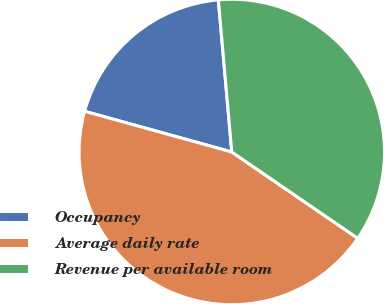<chart> <loc_0><loc_0><loc_500><loc_500><pie_chart><fcel>Occupancy<fcel>Average daily rate<fcel>Revenue per available room<nl><fcel>19.3%<fcel>44.74%<fcel>35.96%<nl></chart> 